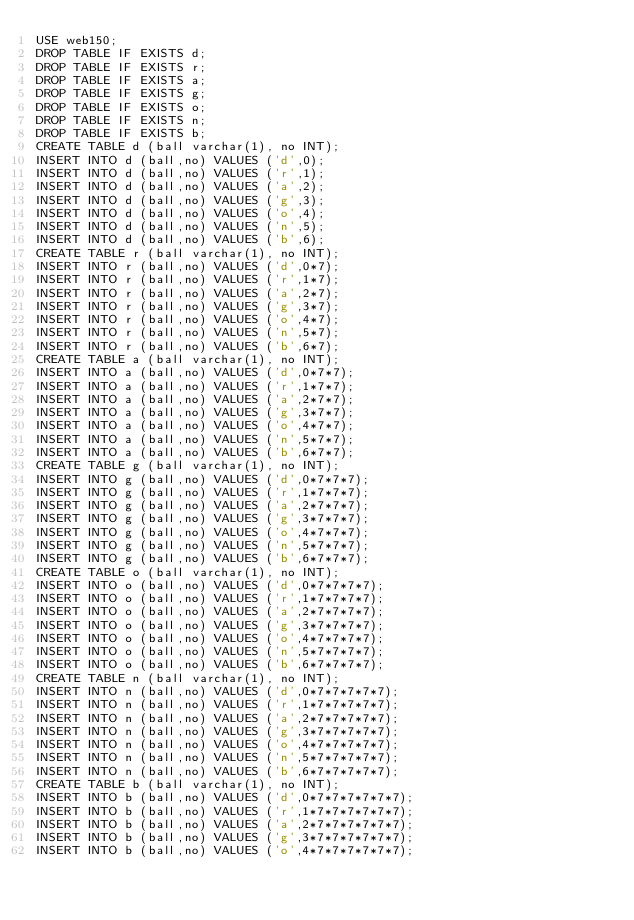<code> <loc_0><loc_0><loc_500><loc_500><_SQL_>USE web150;
DROP TABLE IF EXISTS d;
DROP TABLE IF EXISTS r;
DROP TABLE IF EXISTS a;
DROP TABLE IF EXISTS g;
DROP TABLE IF EXISTS o;
DROP TABLE IF EXISTS n;
DROP TABLE IF EXISTS b;
CREATE TABLE d (ball varchar(1), no INT);
INSERT INTO d (ball,no) VALUES ('d',0);
INSERT INTO d (ball,no) VALUES ('r',1);
INSERT INTO d (ball,no) VALUES ('a',2);
INSERT INTO d (ball,no) VALUES ('g',3);
INSERT INTO d (ball,no) VALUES ('o',4);
INSERT INTO d (ball,no) VALUES ('n',5);
INSERT INTO d (ball,no) VALUES ('b',6);
CREATE TABLE r (ball varchar(1), no INT);
INSERT INTO r (ball,no) VALUES ('d',0*7);
INSERT INTO r (ball,no) VALUES ('r',1*7);
INSERT INTO r (ball,no) VALUES ('a',2*7);
INSERT INTO r (ball,no) VALUES ('g',3*7);
INSERT INTO r (ball,no) VALUES ('o',4*7);
INSERT INTO r (ball,no) VALUES ('n',5*7);
INSERT INTO r (ball,no) VALUES ('b',6*7);
CREATE TABLE a (ball varchar(1), no INT);
INSERT INTO a (ball,no) VALUES ('d',0*7*7);
INSERT INTO a (ball,no) VALUES ('r',1*7*7);
INSERT INTO a (ball,no) VALUES ('a',2*7*7);
INSERT INTO a (ball,no) VALUES ('g',3*7*7);
INSERT INTO a (ball,no) VALUES ('o',4*7*7);
INSERT INTO a (ball,no) VALUES ('n',5*7*7);
INSERT INTO a (ball,no) VALUES ('b',6*7*7);
CREATE TABLE g (ball varchar(1), no INT);
INSERT INTO g (ball,no) VALUES ('d',0*7*7*7);
INSERT INTO g (ball,no) VALUES ('r',1*7*7*7);
INSERT INTO g (ball,no) VALUES ('a',2*7*7*7);
INSERT INTO g (ball,no) VALUES ('g',3*7*7*7);
INSERT INTO g (ball,no) VALUES ('o',4*7*7*7);
INSERT INTO g (ball,no) VALUES ('n',5*7*7*7);
INSERT INTO g (ball,no) VALUES ('b',6*7*7*7);
CREATE TABLE o (ball varchar(1), no INT);
INSERT INTO o (ball,no) VALUES ('d',0*7*7*7*7);
INSERT INTO o (ball,no) VALUES ('r',1*7*7*7*7);
INSERT INTO o (ball,no) VALUES ('a',2*7*7*7*7);
INSERT INTO o (ball,no) VALUES ('g',3*7*7*7*7);
INSERT INTO o (ball,no) VALUES ('o',4*7*7*7*7);
INSERT INTO o (ball,no) VALUES ('n',5*7*7*7*7);
INSERT INTO o (ball,no) VALUES ('b',6*7*7*7*7);
CREATE TABLE n (ball varchar(1), no INT);
INSERT INTO n (ball,no) VALUES ('d',0*7*7*7*7*7);
INSERT INTO n (ball,no) VALUES ('r',1*7*7*7*7*7);
INSERT INTO n (ball,no) VALUES ('a',2*7*7*7*7*7);
INSERT INTO n (ball,no) VALUES ('g',3*7*7*7*7*7);
INSERT INTO n (ball,no) VALUES ('o',4*7*7*7*7*7);
INSERT INTO n (ball,no) VALUES ('n',5*7*7*7*7*7);
INSERT INTO n (ball,no) VALUES ('b',6*7*7*7*7*7);
CREATE TABLE b (ball varchar(1), no INT);
INSERT INTO b (ball,no) VALUES ('d',0*7*7*7*7*7*7);
INSERT INTO b (ball,no) VALUES ('r',1*7*7*7*7*7*7);
INSERT INTO b (ball,no) VALUES ('a',2*7*7*7*7*7*7);
INSERT INTO b (ball,no) VALUES ('g',3*7*7*7*7*7*7);
INSERT INTO b (ball,no) VALUES ('o',4*7*7*7*7*7*7);</code> 